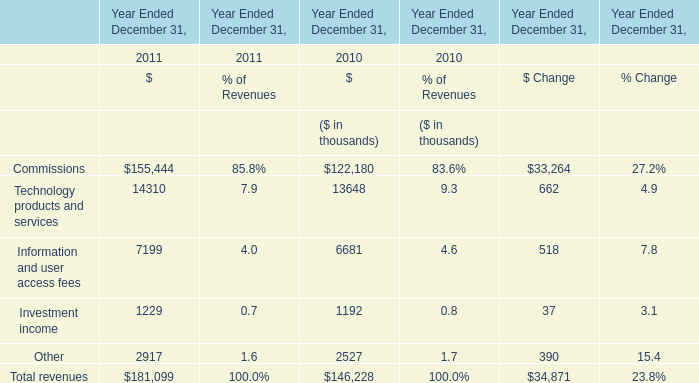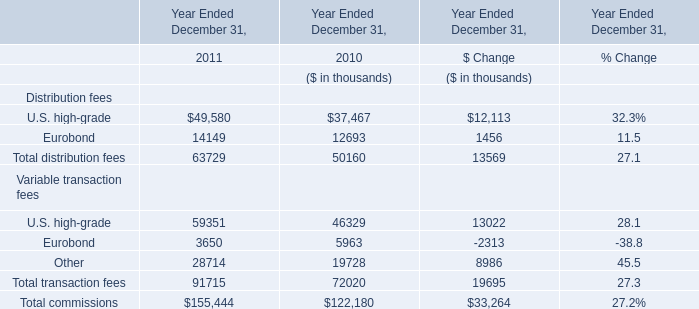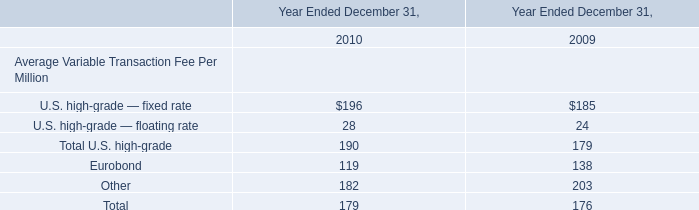Which element has the second largest number in 2011? 
Answer: U.S. high-grade. 